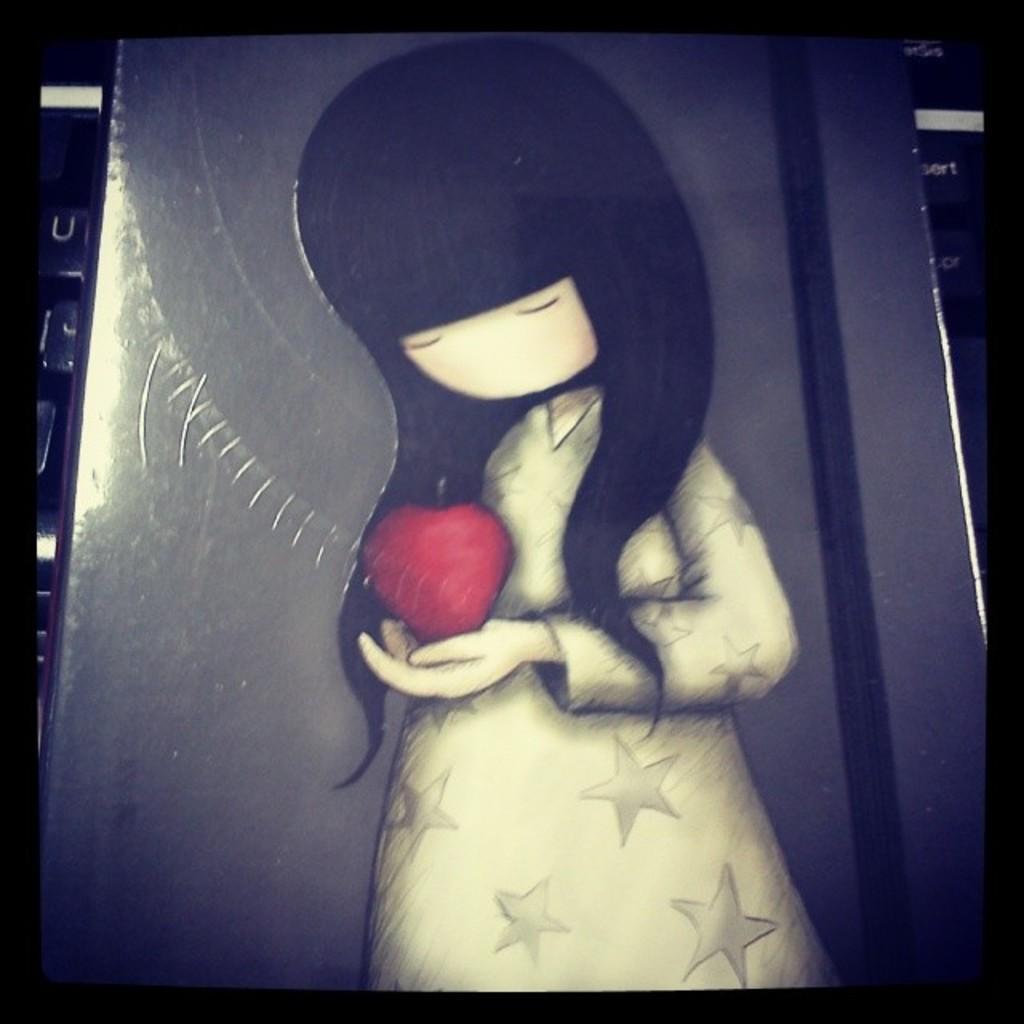Could you give a brief overview of what you see in this image? In this image I can see cartoon of a girl and I can see she is holding a red colour thing. 